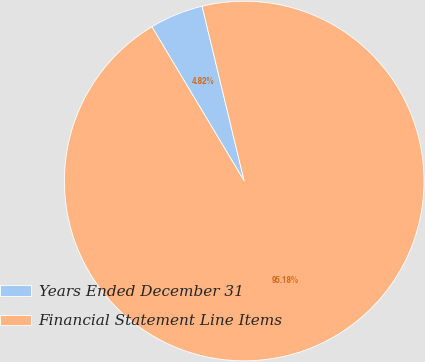<chart> <loc_0><loc_0><loc_500><loc_500><pie_chart><fcel>Years Ended December 31<fcel>Financial Statement Line Items<nl><fcel>4.82%<fcel>95.18%<nl></chart> 